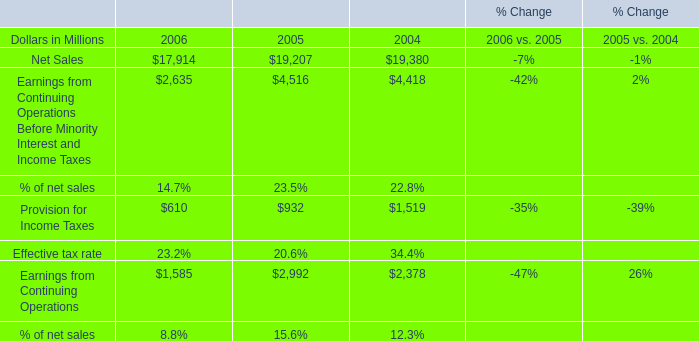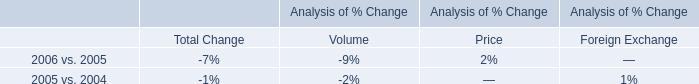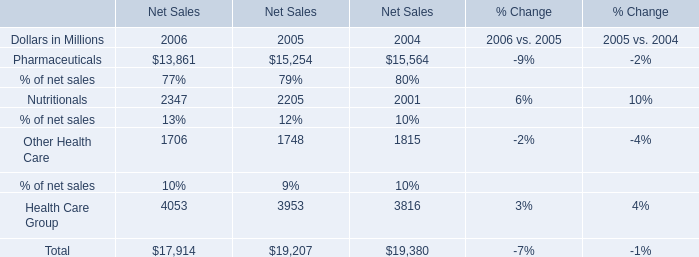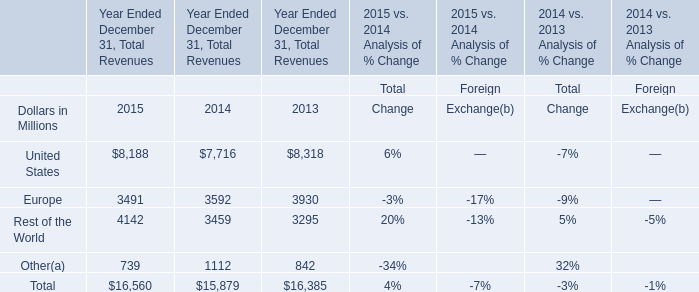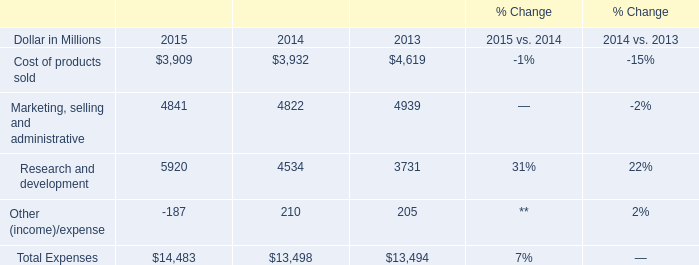In which year is Earnings from Continuing Operations Before Minority Interest and Income Taxes positive? 
Answer: 2006 2005 2004. 